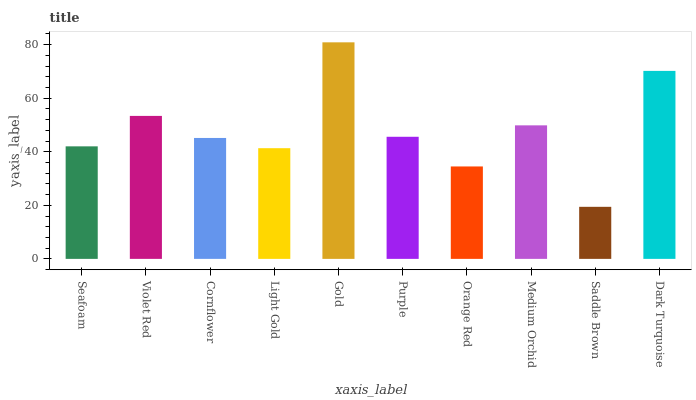Is Saddle Brown the minimum?
Answer yes or no. Yes. Is Gold the maximum?
Answer yes or no. Yes. Is Violet Red the minimum?
Answer yes or no. No. Is Violet Red the maximum?
Answer yes or no. No. Is Violet Red greater than Seafoam?
Answer yes or no. Yes. Is Seafoam less than Violet Red?
Answer yes or no. Yes. Is Seafoam greater than Violet Red?
Answer yes or no. No. Is Violet Red less than Seafoam?
Answer yes or no. No. Is Purple the high median?
Answer yes or no. Yes. Is Cornflower the low median?
Answer yes or no. Yes. Is Seafoam the high median?
Answer yes or no. No. Is Violet Red the low median?
Answer yes or no. No. 